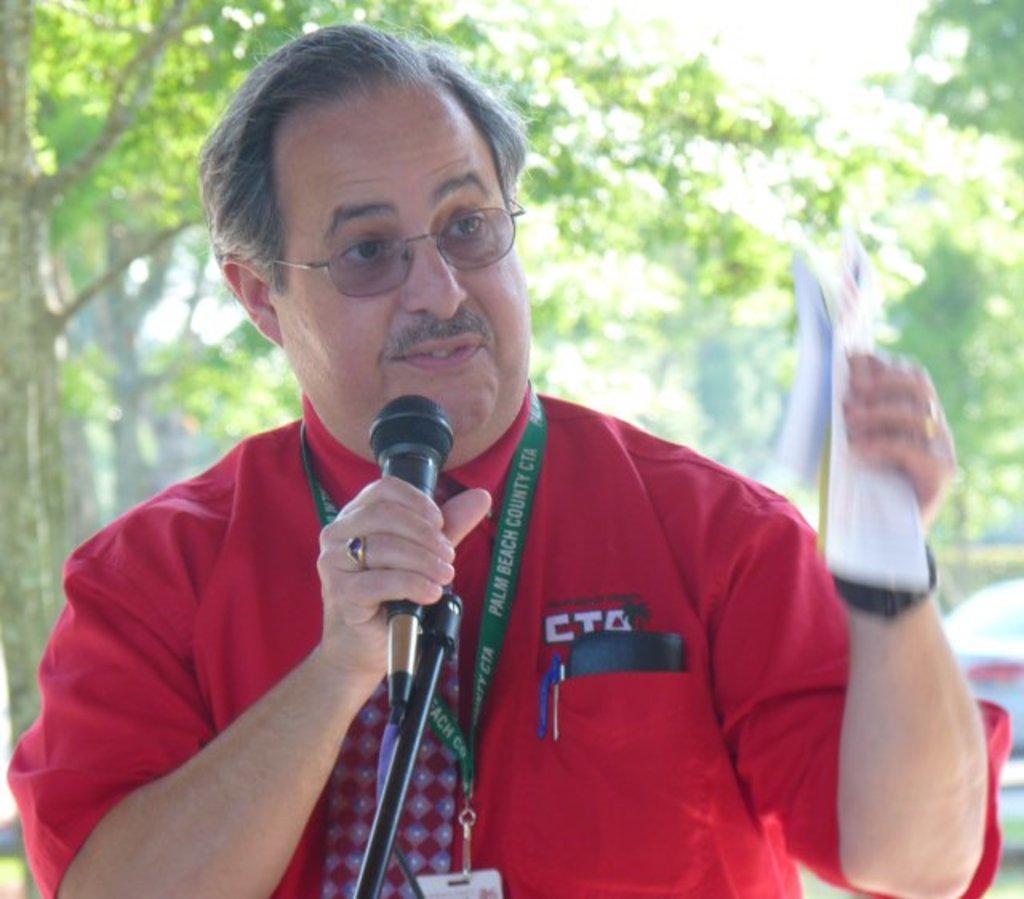Can you describe this image briefly? In the center of the image we can see a person is holding a microphone and some object. And we can see he is wearing glasses and he is in a different costume. In the background, we can see it is blurred. 